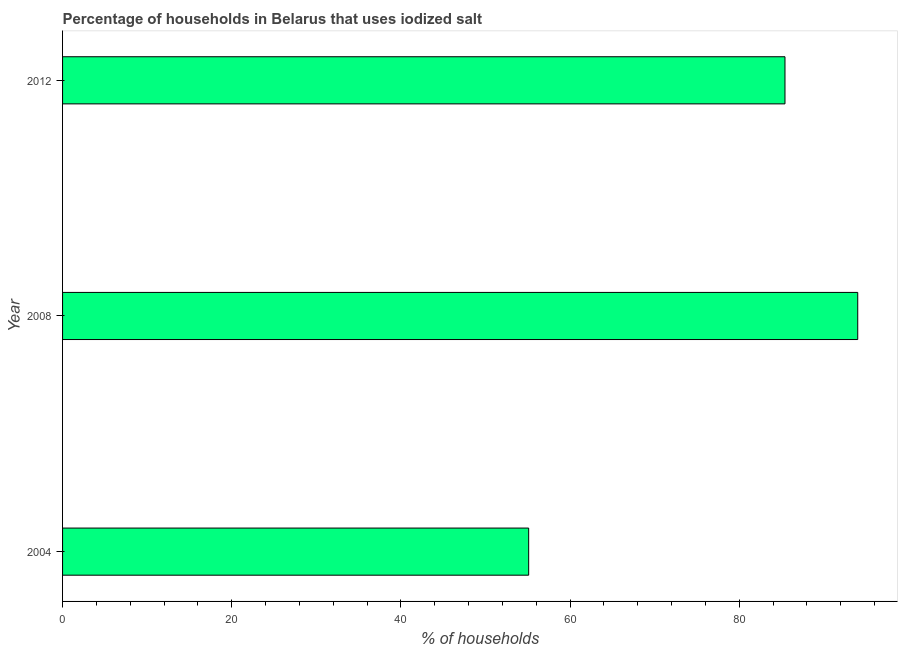Does the graph contain any zero values?
Provide a succinct answer. No. What is the title of the graph?
Your answer should be compact. Percentage of households in Belarus that uses iodized salt. What is the label or title of the X-axis?
Your answer should be compact. % of households. What is the percentage of households where iodized salt is consumed in 2012?
Ensure brevity in your answer.  85.4. Across all years, what is the maximum percentage of households where iodized salt is consumed?
Your answer should be compact. 94. Across all years, what is the minimum percentage of households where iodized salt is consumed?
Your answer should be very brief. 55.1. In which year was the percentage of households where iodized salt is consumed minimum?
Offer a terse response. 2004. What is the sum of the percentage of households where iodized salt is consumed?
Give a very brief answer. 234.5. What is the difference between the percentage of households where iodized salt is consumed in 2004 and 2012?
Your answer should be very brief. -30.3. What is the average percentage of households where iodized salt is consumed per year?
Your response must be concise. 78.17. What is the median percentage of households where iodized salt is consumed?
Make the answer very short. 85.4. In how many years, is the percentage of households where iodized salt is consumed greater than 64 %?
Offer a terse response. 2. What is the ratio of the percentage of households where iodized salt is consumed in 2004 to that in 2008?
Provide a short and direct response. 0.59. Is the percentage of households where iodized salt is consumed in 2004 less than that in 2008?
Keep it short and to the point. Yes. What is the difference between the highest and the lowest percentage of households where iodized salt is consumed?
Your response must be concise. 38.9. How many years are there in the graph?
Ensure brevity in your answer.  3. What is the % of households of 2004?
Provide a succinct answer. 55.1. What is the % of households in 2008?
Ensure brevity in your answer.  94. What is the % of households of 2012?
Your answer should be very brief. 85.4. What is the difference between the % of households in 2004 and 2008?
Provide a succinct answer. -38.9. What is the difference between the % of households in 2004 and 2012?
Provide a short and direct response. -30.3. What is the ratio of the % of households in 2004 to that in 2008?
Ensure brevity in your answer.  0.59. What is the ratio of the % of households in 2004 to that in 2012?
Provide a succinct answer. 0.65. What is the ratio of the % of households in 2008 to that in 2012?
Your answer should be compact. 1.1. 